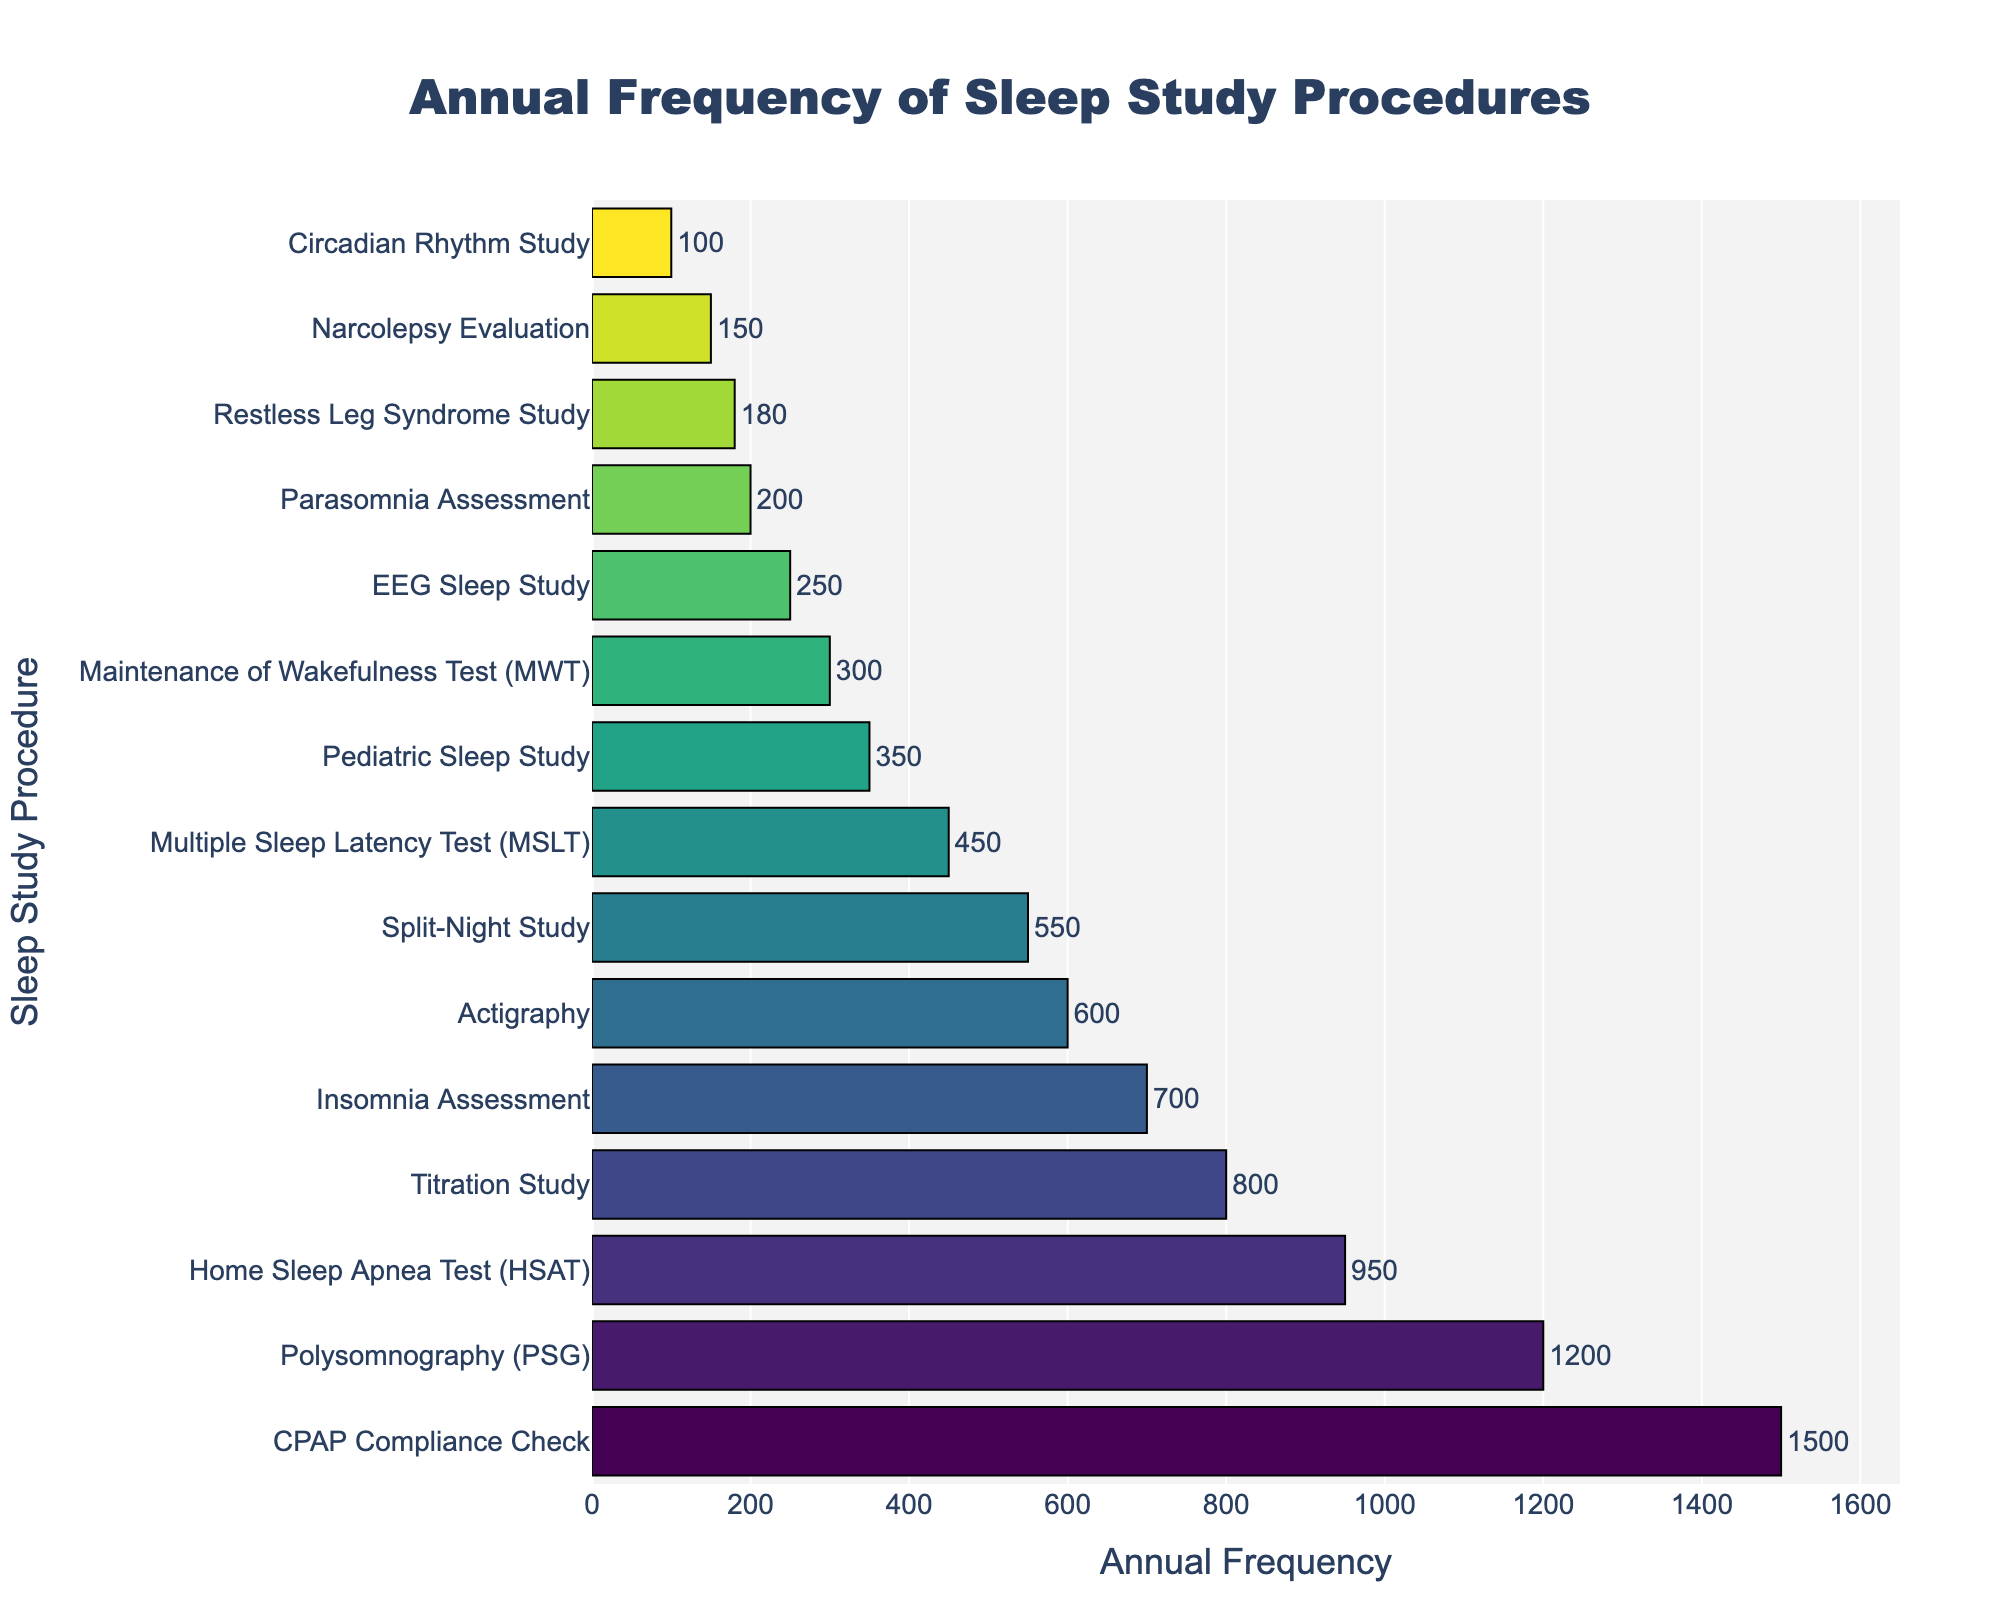What's the most frequently performed sleep study procedure? Let's look at the bar representing the sleep study procedure with the greatest length, which corresponds to the highest value on the x-axis. The bar for "CPAP Compliance Check" extends to 1500.
Answer: CPAP Compliance Check Which sleep study procedure is performed more frequently: Actigraphy or Split-Night Study? Compare the lengths of the bars for Actigraphy and Split-Night Study. Actigraphy's bar reaches up to 600 whereas Split-Night Study's bar reaches up to 550.
Answer: Actigraphy How much more frequent is Polysomnography (PSG) compared to Narcolepsy Evaluation? Find the frequencies for Polysomnography (1200) and Narcolepsy Evaluation (150). Subtract the smaller value from the larger one: 1200 - 150 = 1050.
Answer: 1050 What is the sum of the frequencies for Multiple Sleep Latency Test (MSLT) and Insomnia Assessment? Find the frequencies for MSLT (450) and Insomnia Assessment (700). Add these two values: 450 + 700 = 1150.
Answer: 1150 Which sleep study procedures have an annual frequency greater than 1000? Identify all bars that extend beyond the 1000 mark on the x-axis. The study procedures are "Polysomnography (PSG)" (1200) and "CPAP Compliance Check" (1500).
Answer: Polysomnography (PSG), CPAP Compliance Check What is the difference between the annual frequency of Titration Study and Pediatric Sleep Study? Find the frequencies for Titration Study (800) and Pediatric Sleep Study (350). Subtract the smaller frequency from the larger one: 800 - 350 = 450.
Answer: 450 Which sleep study procedure has the lowest frequency? Identify the bar with the smallest length on the x-axis, representing the lowest frequency. The shortest bar is for "Circadian Rhythm Study" with a frequency of 100.
Answer: Circadian Rhythm Study How many sleep study procedures have an annual frequency less than 300? Look for bars that extend up to the 300 mark on the x-axis and count them. These procedures are "Circadian Rhythm Study" (100), "Narcolepsy Evaluation" (150), "Parasomnia Assessment" (200), "EEG Sleep Study" (250), and "Restless Leg Syndrome Study" (180). Count them: 5.
Answer: 5 